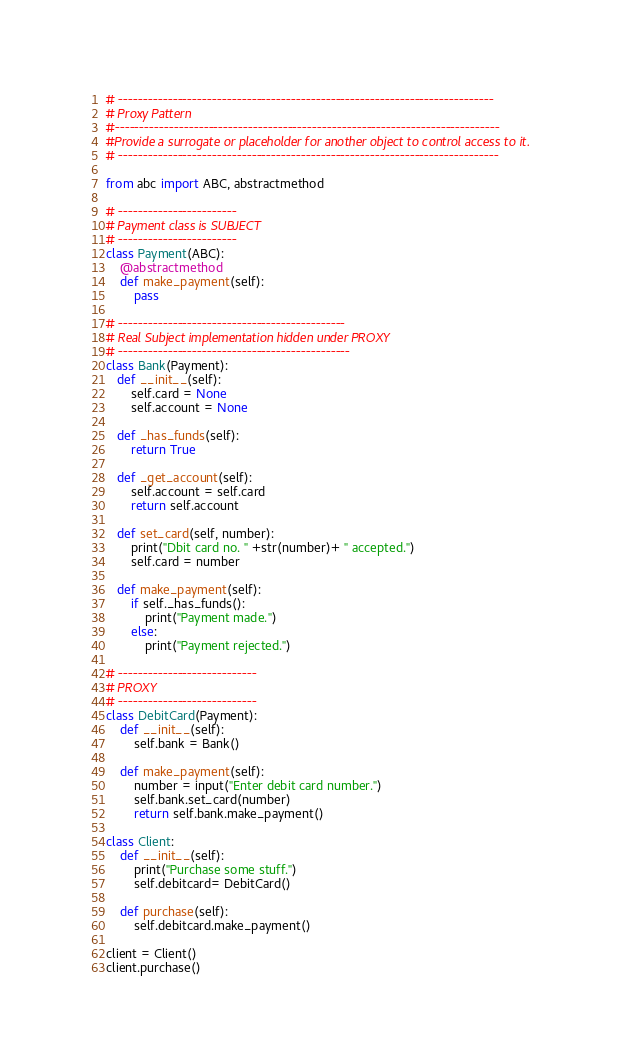Convert code to text. <code><loc_0><loc_0><loc_500><loc_500><_Python_># ----------------------------------------------------------------------------
# Proxy Pattern
#------------------------------------------------------------------------------
#Provide a surrogate or placeholder for another object to control access to it.
# -----------------------------------------------------------------------------

from abc import ABC, abstractmethod

# ------------------------
# Payment class is SUBJECT
# ------------------------
class Payment(ABC):
    @abstractmethod
    def make_payment(self):
        pass

# ----------------------------------------------
# Real Subject implementation hidden under PROXY
# -----------------------------------------------
class Bank(Payment):
   def __init__(self):
       self.card = None
       self.account = None

   def _has_funds(self):
       return True

   def _get_account(self):
       self.account = self.card
       return self.account

   def set_card(self, number):
       print("Dbit card no. " +str(number)+ " accepted.")
       self.card = number

   def make_payment(self):
       if self._has_funds():
           print("Payment made.")
       else:
           print("Payment rejected.")

# ----------------------------
# PROXY
# ----------------------------
class DebitCard(Payment):
    def __init__(self):
        self.bank = Bank()

    def make_payment(self):
        number = input("Enter debit card number.")
        self.bank.set_card(number)
        return self.bank.make_payment()

class Client:
    def __init__(self):
        print("Purchase some stuff.")
        self.debitcard= DebitCard()

    def purchase(self):
        self.debitcard.make_payment()

client = Client()
client.purchase()

</code> 